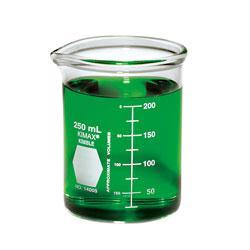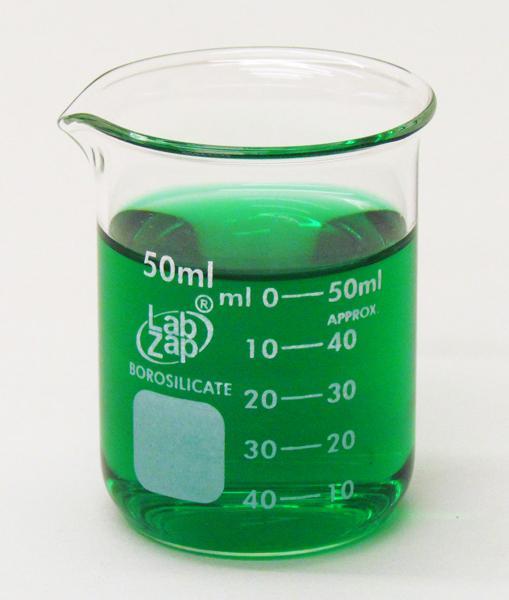The first image is the image on the left, the second image is the image on the right. Analyze the images presented: Is the assertion "The left beaker has a top mark labeled as 40 ml." valid? Answer yes or no. No. 